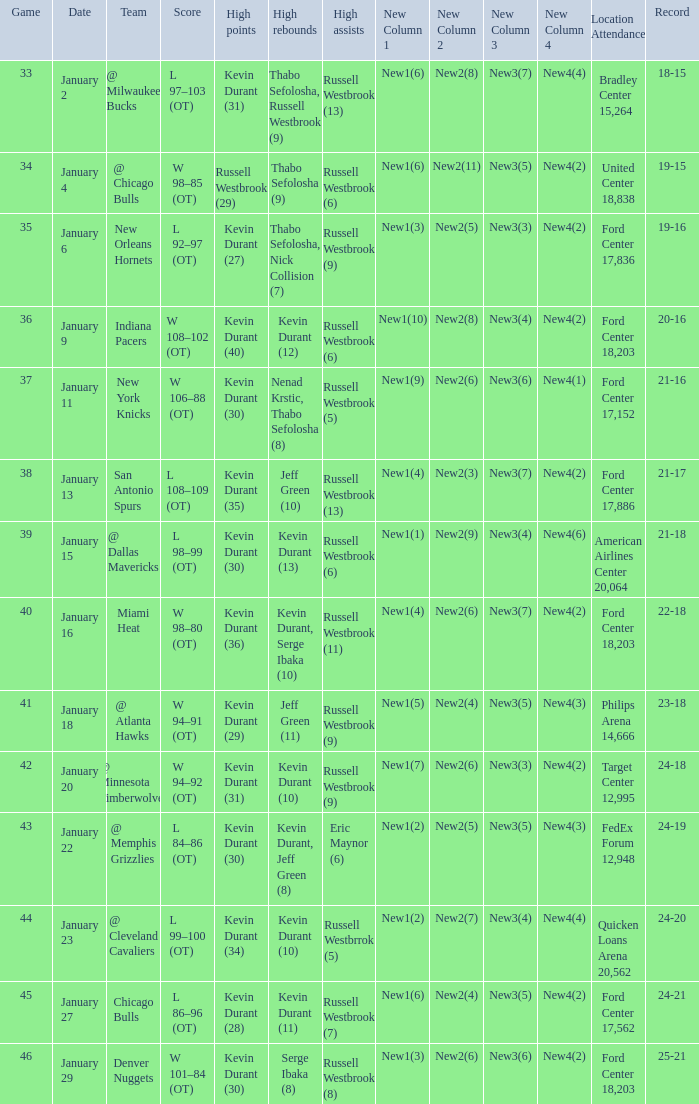Name the location attendance for january 18 Philips Arena 14,666. 